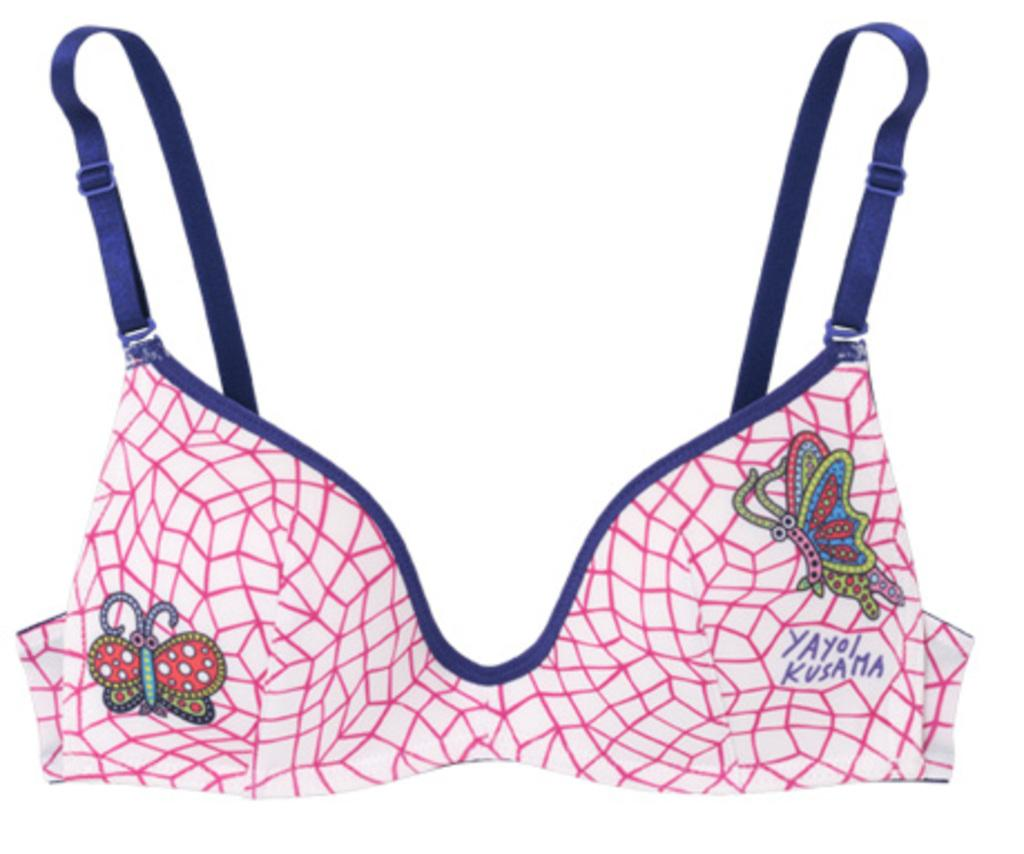What type of item is featured in the image? There are clothes in the image. Can you describe the appearance of the clothes? The clothes have a design and writing on them. What is the color of the background in the image? The background of the image is white. Can you see any sand or a dock in the image? No, there is no sand or dock present in the image. Is there a carpenter working on the clothes in the image? There is no carpenter present in the image, and the clothes are not being worked on by anyone. 